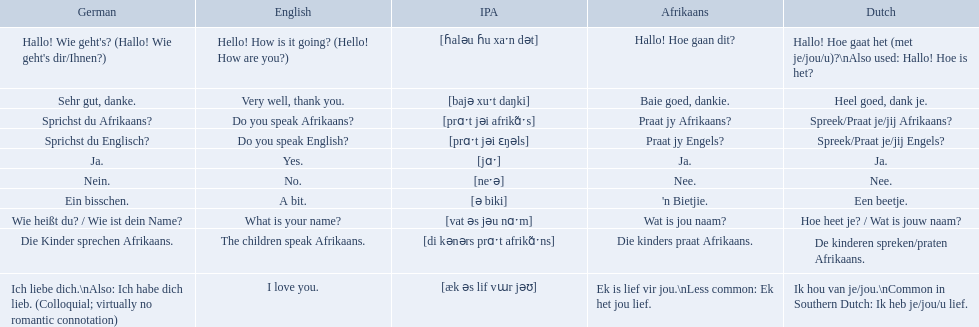What are the afrikaans phrases? Hallo! Hoe gaan dit?, Baie goed, dankie., Praat jy Afrikaans?, Praat jy Engels?, Ja., Nee., 'n Bietjie., Wat is jou naam?, Die kinders praat Afrikaans., Ek is lief vir jou.\nLess common: Ek het jou lief. For die kinders praat afrikaans, what are the translations? De kinderen spreken/praten Afrikaans., The children speak Afrikaans., Die Kinder sprechen Afrikaans. Which one is the german translation? Die Kinder sprechen Afrikaans. 